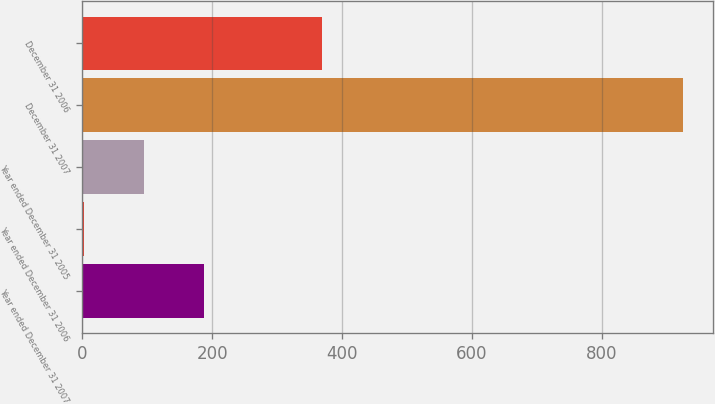Convert chart to OTSL. <chart><loc_0><loc_0><loc_500><loc_500><bar_chart><fcel>Year ended December 31 2007<fcel>Year ended December 31 2006<fcel>Year ended December 31 2005<fcel>December 31 2007<fcel>December 31 2006<nl><fcel>186.86<fcel>2.3<fcel>94.58<fcel>925.1<fcel>369.6<nl></chart> 